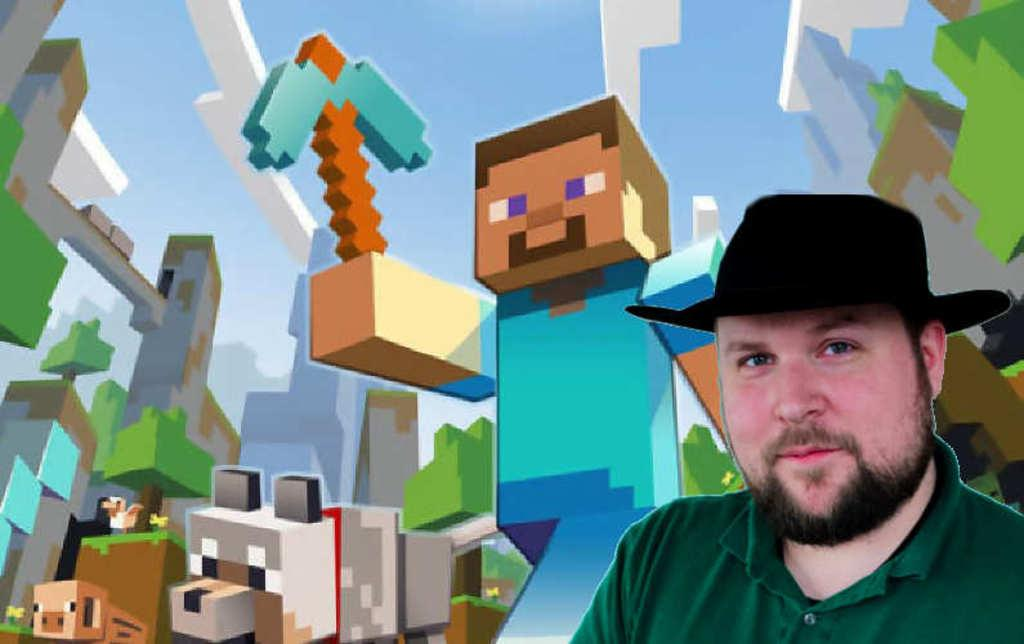What is located on the left side of the image? There is a person on the left side of the image. What is the person wearing on their upper body? The person is wearing a green T-shirt. What type of headwear is the person wearing? The person is wearing a black cap. What expression does the person have? The person is smiling. What can be seen in the background of the image? There are animated objects in the background of the image. What color is the sky in the image? The sky is blue in the image. What type of meat is being cooked on the grill in the image? There is no grill or meat present in the image. What type of flag is being waved by the person in the image? There is no flag present in the image. 